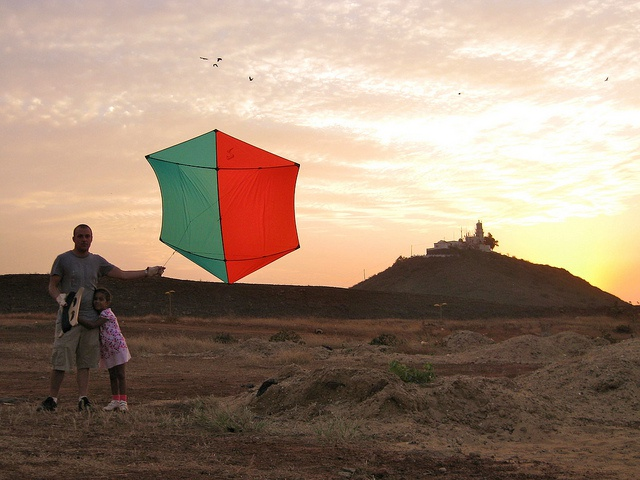Describe the objects in this image and their specific colors. I can see kite in darkgray, red, and teal tones, people in darkgray, black, and gray tones, people in darkgray, black, gray, maroon, and purple tones, bird in darkgray, ivory, gray, and black tones, and bird in darkgray, gray, and tan tones in this image. 